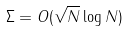<formula> <loc_0><loc_0><loc_500><loc_500>\Sigma = O ( \sqrt { N } \log N )</formula> 